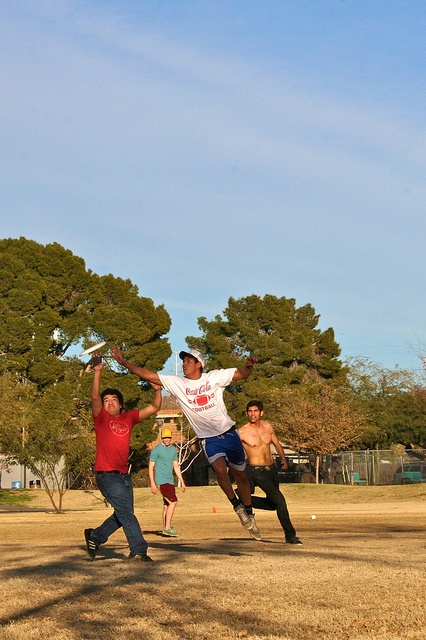Describe the objects in this image and their specific colors. I can see people in lightblue, white, black, maroon, and olive tones, people in lightblue, black, brown, and maroon tones, people in lightblue, black, orange, brown, and maroon tones, people in lightblue, teal, tan, and maroon tones, and car in lightblue, gray, and black tones in this image. 